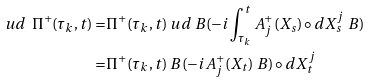<formula> <loc_0><loc_0><loc_500><loc_500>\ u d \ \Pi ^ { + } ( \tau _ { k } , t ) = & \Pi ^ { + } ( \tau _ { k } , t ) \ u d \ B ( - i \int ^ { t } _ { \tau _ { k } } A ^ { + } _ { j } ( X _ { s } ) \circ d X ^ { j } _ { s } \ B ) \\ = & \Pi ^ { + } ( \tau _ { k } , t ) \ B ( - i A ^ { + } _ { j } ( X _ { t } ) \ B ) \circ d X ^ { j } _ { t } \\</formula> 